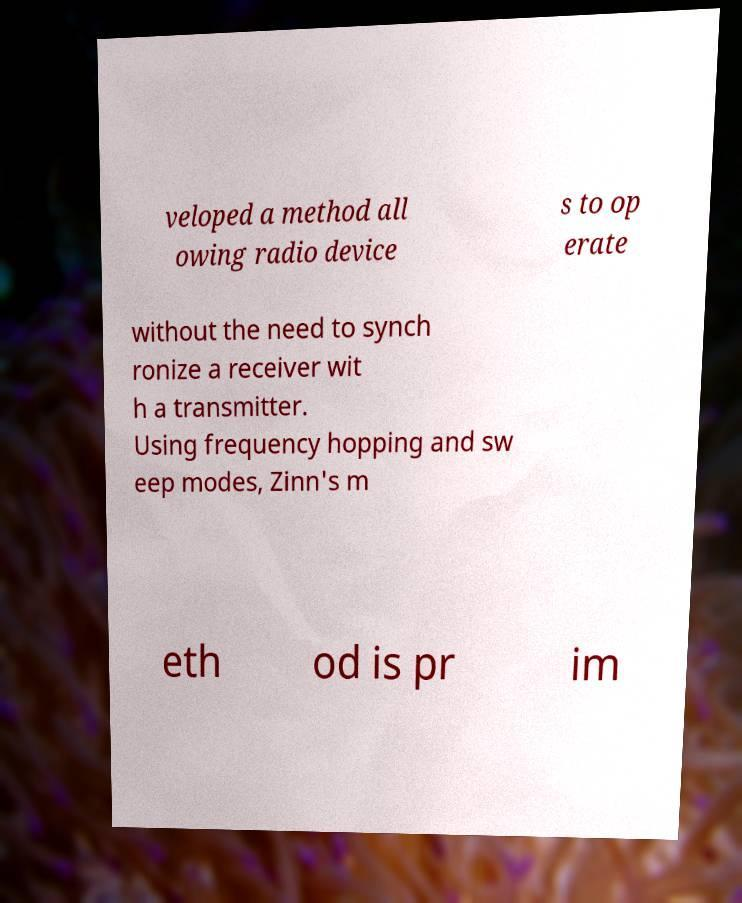Could you extract and type out the text from this image? veloped a method all owing radio device s to op erate without the need to synch ronize a receiver wit h a transmitter. Using frequency hopping and sw eep modes, Zinn's m eth od is pr im 